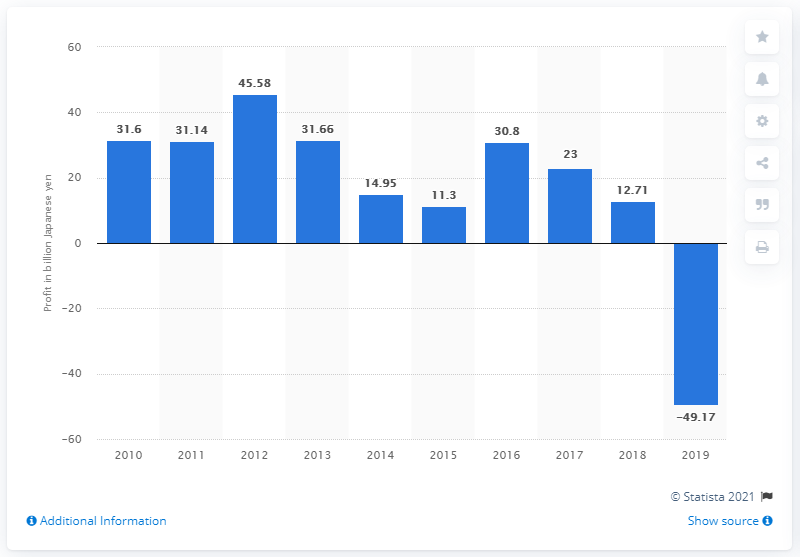Draw attention to some important aspects in this diagram. DeNA Co., Ltd. made 12,710,000 yen in the previous fiscal year. 